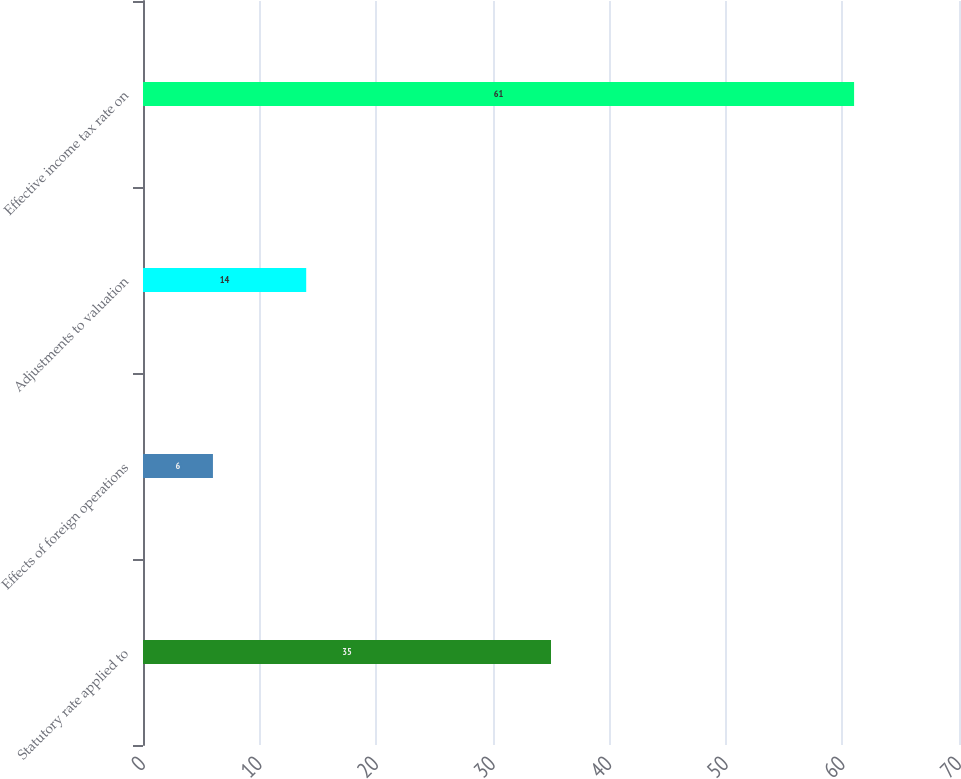Convert chart. <chart><loc_0><loc_0><loc_500><loc_500><bar_chart><fcel>Statutory rate applied to<fcel>Effects of foreign operations<fcel>Adjustments to valuation<fcel>Effective income tax rate on<nl><fcel>35<fcel>6<fcel>14<fcel>61<nl></chart> 